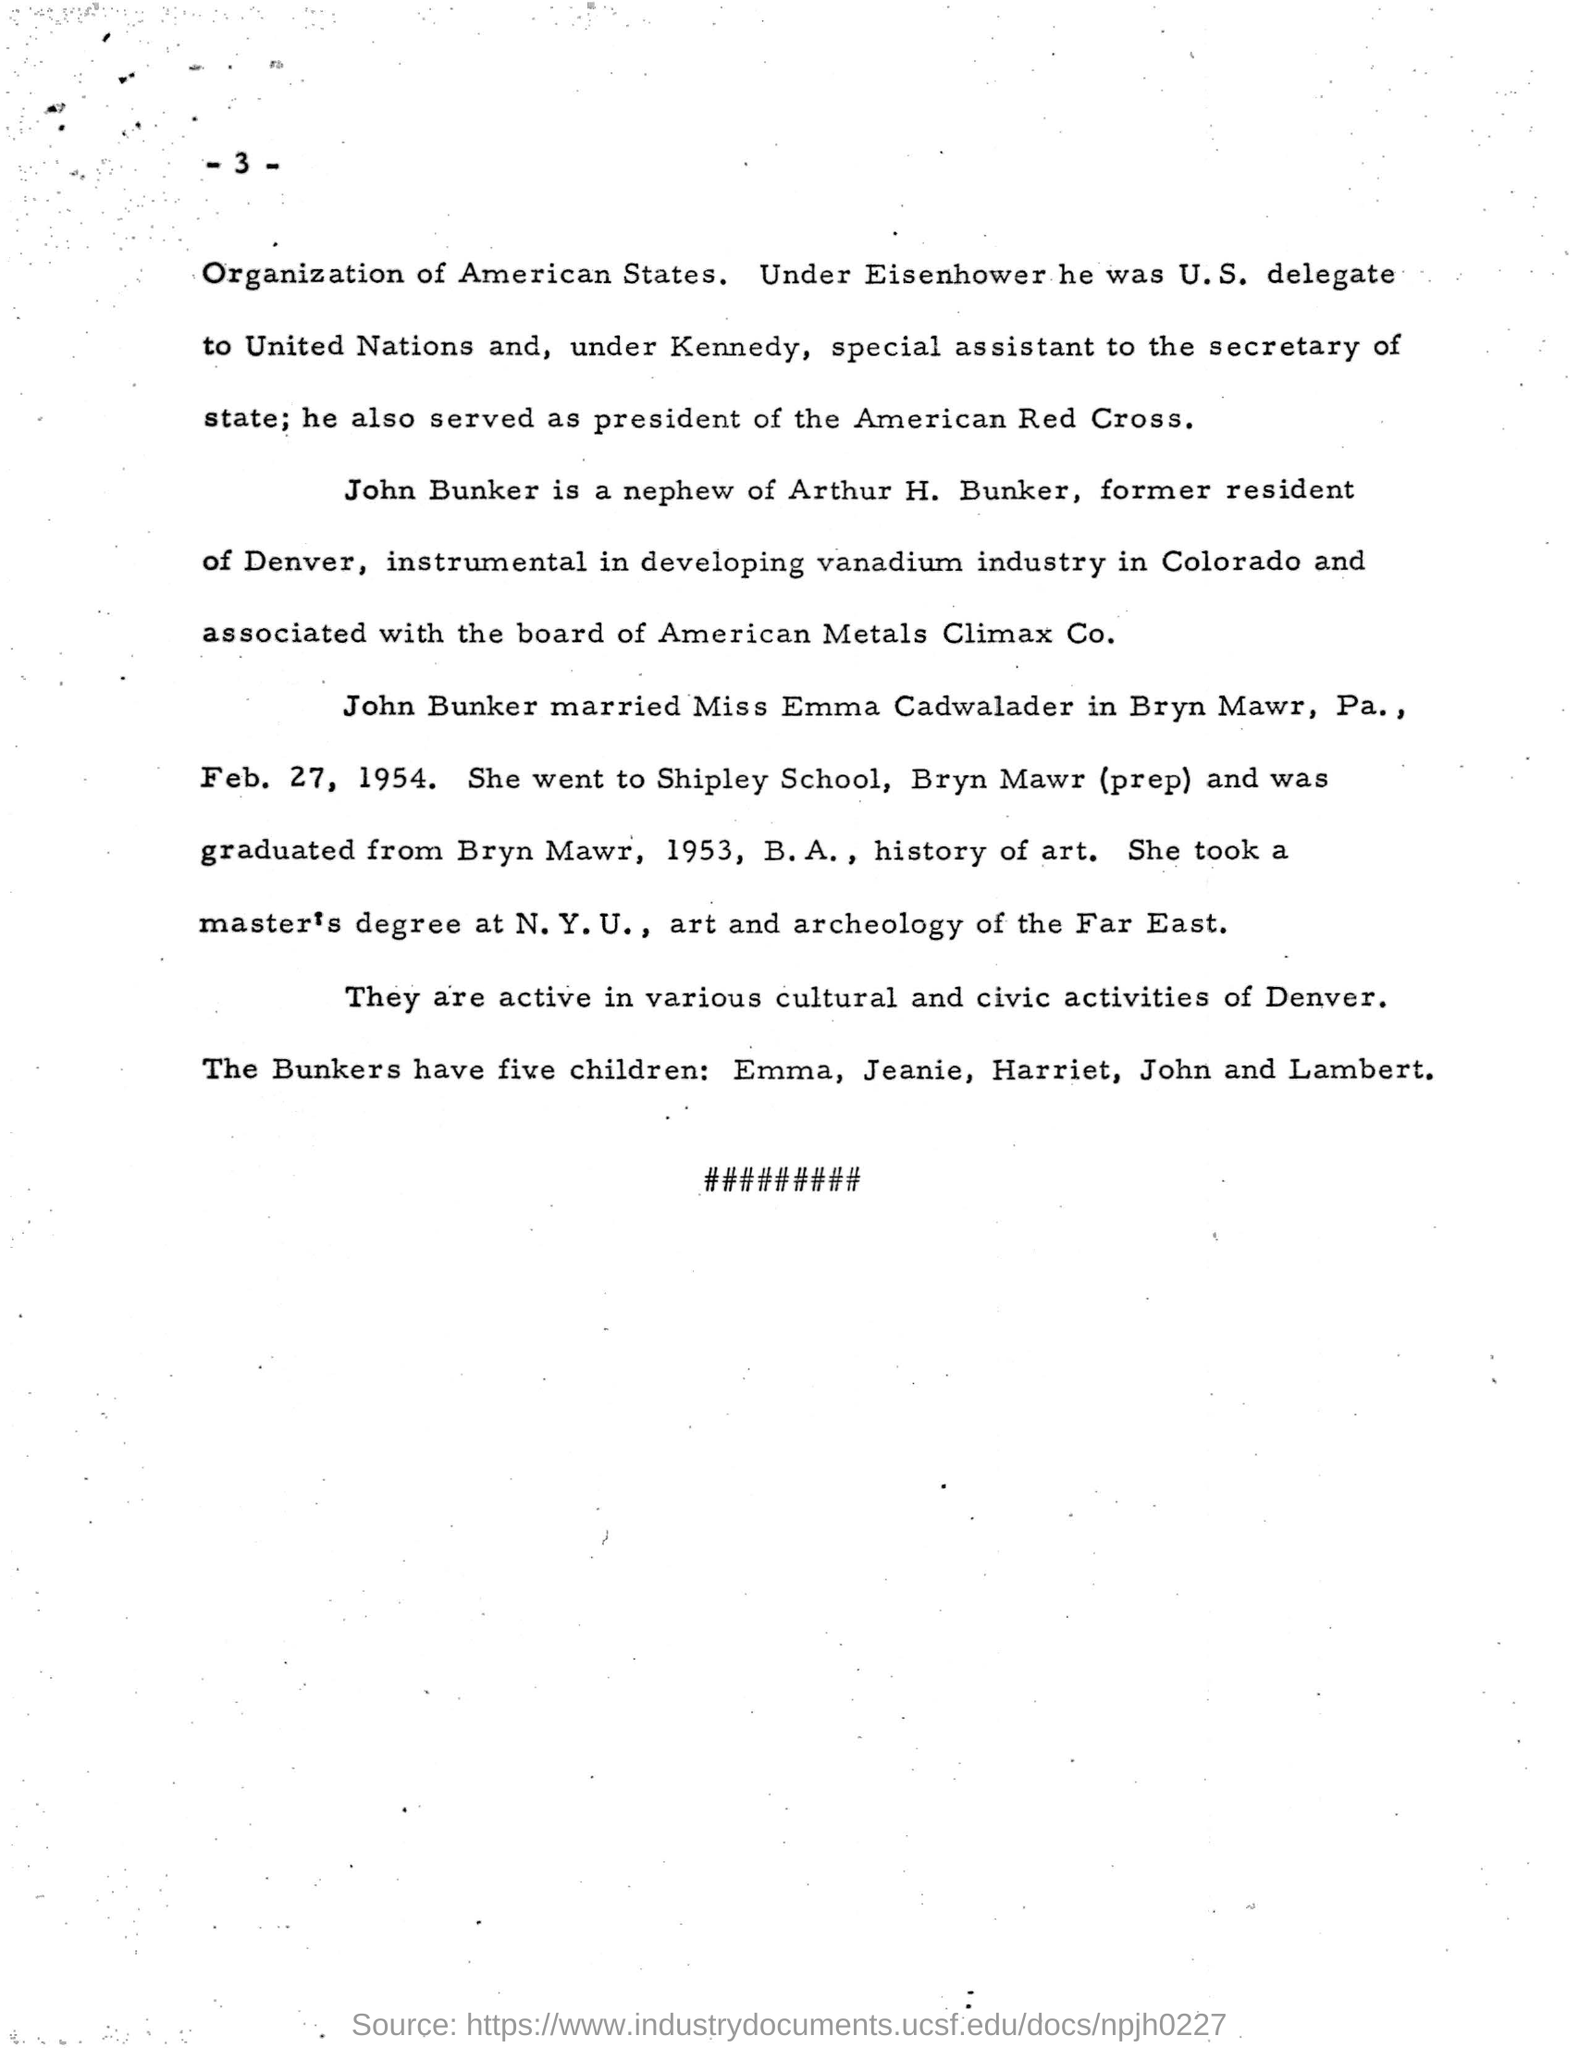Nephew of arthur h bunker
Provide a succinct answer. John Bunker. Who is assoicated with the board of american metals climax co.
Your answer should be compact. John Bunker. Whom did john bunker marry
Offer a very short reply. Miss Emma Cadwalader. Which school did miss emma cadwalader go
Your answer should be very brief. Shipley School. 